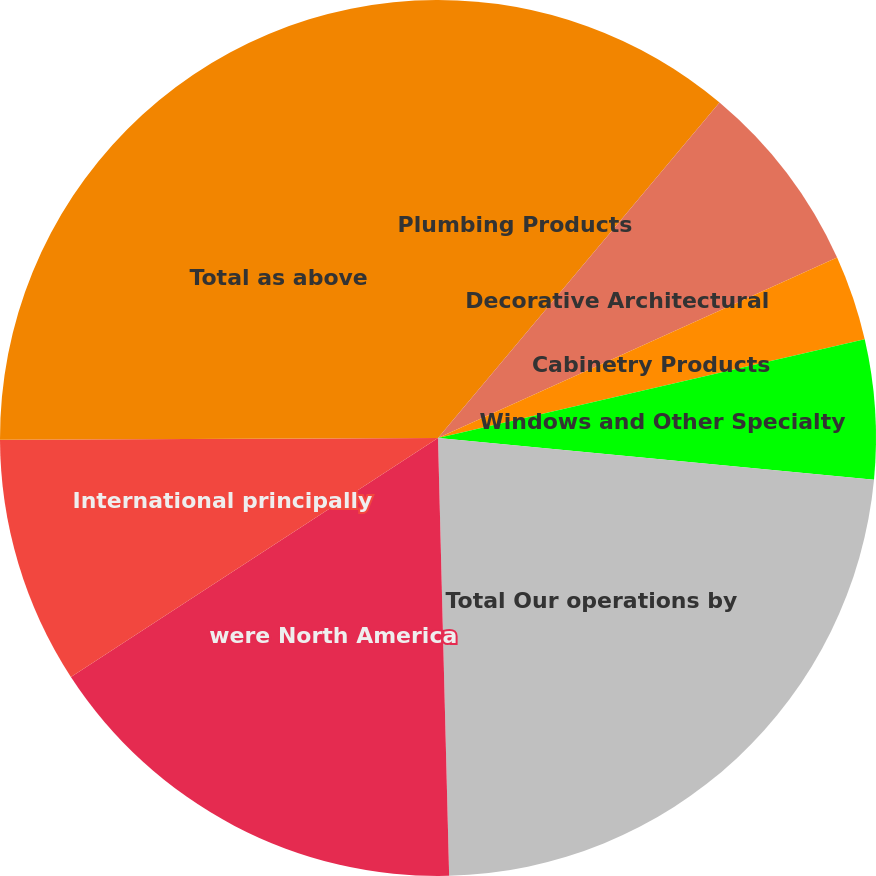Convert chart. <chart><loc_0><loc_0><loc_500><loc_500><pie_chart><fcel>Plumbing Products<fcel>Decorative Architectural<fcel>Cabinetry Products<fcel>Windows and Other Specialty<fcel>Total Our operations by<fcel>were North America<fcel>International principally<fcel>Total as above<nl><fcel>11.11%<fcel>7.13%<fcel>3.14%<fcel>5.14%<fcel>23.07%<fcel>16.22%<fcel>9.12%<fcel>25.06%<nl></chart> 